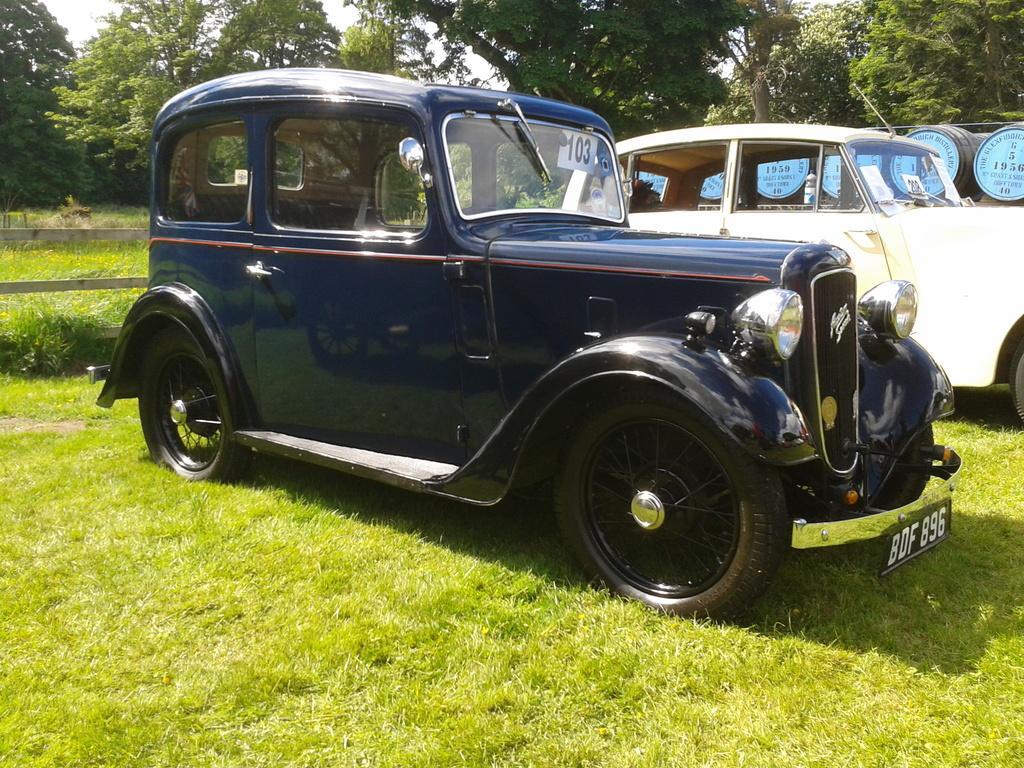Please provide a concise description of this image. In this image I can see two vehicles, in front the vehicle is in blue color and the other vehicle is in white color. Background I can see grass and trees in green color and sky is in white color. 